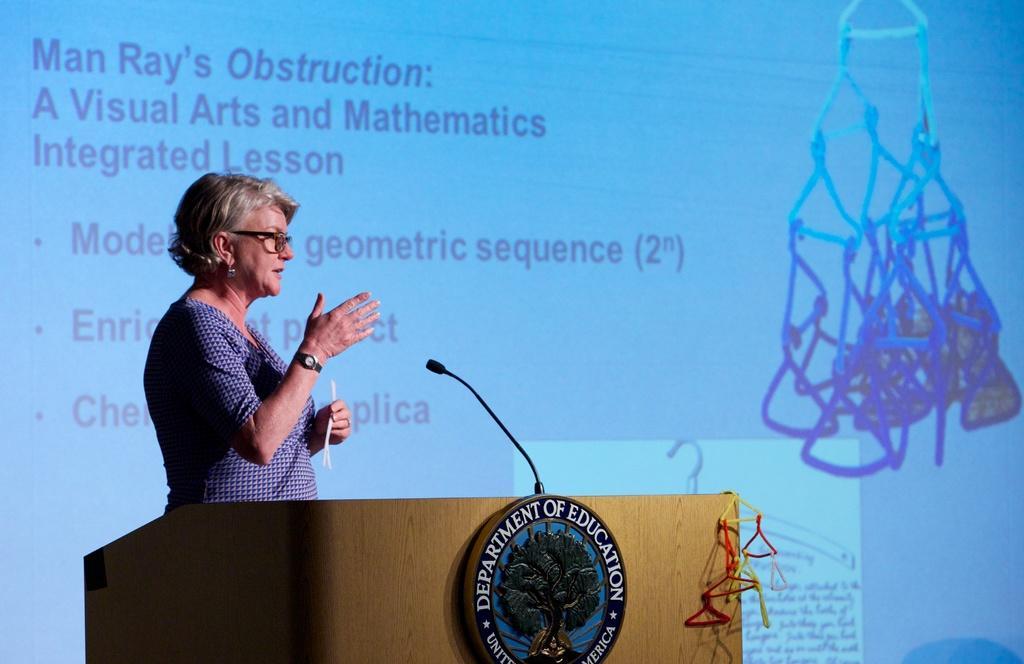Could you give a brief overview of what you see in this image? There is a lady wearing specs and watch is holding something in the hand. In front of them there is a podium with mic. On the podium there is an emblem with something written. In the back there is a screen with something written. And there is an object image on the screen. On the podium there is an object. 